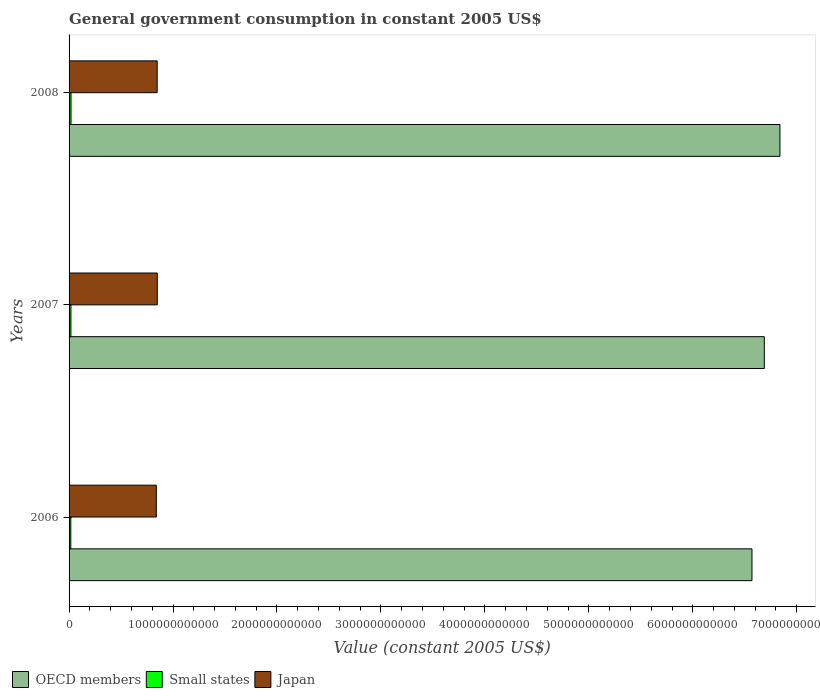How many different coloured bars are there?
Provide a short and direct response. 3. How many groups of bars are there?
Your response must be concise. 3. Are the number of bars on each tick of the Y-axis equal?
Your answer should be very brief. Yes. How many bars are there on the 1st tick from the top?
Your answer should be compact. 3. How many bars are there on the 2nd tick from the bottom?
Provide a short and direct response. 3. What is the label of the 3rd group of bars from the top?
Make the answer very short. 2006. In how many cases, is the number of bars for a given year not equal to the number of legend labels?
Ensure brevity in your answer.  0. What is the government conusmption in Small states in 2006?
Make the answer very short. 1.67e+1. Across all years, what is the maximum government conusmption in Japan?
Keep it short and to the point. 8.49e+11. Across all years, what is the minimum government conusmption in Small states?
Give a very brief answer. 1.67e+1. What is the total government conusmption in Small states in the graph?
Your answer should be compact. 5.32e+1. What is the difference between the government conusmption in Small states in 2006 and that in 2007?
Offer a very short reply. -1.14e+09. What is the difference between the government conusmption in Small states in 2006 and the government conusmption in Japan in 2008?
Make the answer very short. -8.31e+11. What is the average government conusmption in Japan per year?
Ensure brevity in your answer.  8.45e+11. In the year 2006, what is the difference between the government conusmption in Japan and government conusmption in OECD members?
Offer a terse response. -5.73e+12. In how many years, is the government conusmption in OECD members greater than 6400000000000 US$?
Offer a terse response. 3. What is the ratio of the government conusmption in OECD members in 2006 to that in 2007?
Provide a succinct answer. 0.98. Is the government conusmption in Japan in 2006 less than that in 2008?
Your answer should be compact. Yes. Is the difference between the government conusmption in Japan in 2006 and 2007 greater than the difference between the government conusmption in OECD members in 2006 and 2007?
Your answer should be compact. Yes. What is the difference between the highest and the second highest government conusmption in Small states?
Your response must be concise. 8.44e+08. What is the difference between the highest and the lowest government conusmption in Japan?
Offer a very short reply. 9.33e+09. Is the sum of the government conusmption in Japan in 2006 and 2008 greater than the maximum government conusmption in Small states across all years?
Offer a very short reply. Yes. What does the 3rd bar from the bottom in 2008 represents?
Provide a succinct answer. Japan. Is it the case that in every year, the sum of the government conusmption in OECD members and government conusmption in Japan is greater than the government conusmption in Small states?
Give a very brief answer. Yes. How many years are there in the graph?
Offer a terse response. 3. What is the difference between two consecutive major ticks on the X-axis?
Give a very brief answer. 1.00e+12. Are the values on the major ticks of X-axis written in scientific E-notation?
Give a very brief answer. No. What is the title of the graph?
Your answer should be very brief. General government consumption in constant 2005 US$. What is the label or title of the X-axis?
Your answer should be compact. Value (constant 2005 US$). What is the Value (constant 2005 US$) of OECD members in 2006?
Your answer should be very brief. 6.57e+12. What is the Value (constant 2005 US$) of Small states in 2006?
Make the answer very short. 1.67e+1. What is the Value (constant 2005 US$) in Japan in 2006?
Provide a short and direct response. 8.39e+11. What is the Value (constant 2005 US$) of OECD members in 2007?
Offer a very short reply. 6.69e+12. What is the Value (constant 2005 US$) of Small states in 2007?
Offer a terse response. 1.78e+1. What is the Value (constant 2005 US$) in Japan in 2007?
Provide a succinct answer. 8.49e+11. What is the Value (constant 2005 US$) in OECD members in 2008?
Keep it short and to the point. 6.84e+12. What is the Value (constant 2005 US$) in Small states in 2008?
Provide a short and direct response. 1.87e+1. What is the Value (constant 2005 US$) in Japan in 2008?
Make the answer very short. 8.47e+11. Across all years, what is the maximum Value (constant 2005 US$) of OECD members?
Provide a succinct answer. 6.84e+12. Across all years, what is the maximum Value (constant 2005 US$) in Small states?
Give a very brief answer. 1.87e+1. Across all years, what is the maximum Value (constant 2005 US$) in Japan?
Provide a succinct answer. 8.49e+11. Across all years, what is the minimum Value (constant 2005 US$) in OECD members?
Your answer should be very brief. 6.57e+12. Across all years, what is the minimum Value (constant 2005 US$) in Small states?
Provide a short and direct response. 1.67e+1. Across all years, what is the minimum Value (constant 2005 US$) of Japan?
Your response must be concise. 8.39e+11. What is the total Value (constant 2005 US$) of OECD members in the graph?
Keep it short and to the point. 2.01e+13. What is the total Value (constant 2005 US$) of Small states in the graph?
Your answer should be very brief. 5.32e+1. What is the total Value (constant 2005 US$) of Japan in the graph?
Provide a short and direct response. 2.54e+12. What is the difference between the Value (constant 2005 US$) of OECD members in 2006 and that in 2007?
Your answer should be very brief. -1.19e+11. What is the difference between the Value (constant 2005 US$) of Small states in 2006 and that in 2007?
Your answer should be very brief. -1.14e+09. What is the difference between the Value (constant 2005 US$) of Japan in 2006 and that in 2007?
Make the answer very short. -9.33e+09. What is the difference between the Value (constant 2005 US$) in OECD members in 2006 and that in 2008?
Give a very brief answer. -2.69e+11. What is the difference between the Value (constant 2005 US$) of Small states in 2006 and that in 2008?
Your answer should be very brief. -1.98e+09. What is the difference between the Value (constant 2005 US$) in Japan in 2006 and that in 2008?
Your answer should be compact. -8.26e+09. What is the difference between the Value (constant 2005 US$) in OECD members in 2007 and that in 2008?
Your response must be concise. -1.50e+11. What is the difference between the Value (constant 2005 US$) in Small states in 2007 and that in 2008?
Provide a succinct answer. -8.44e+08. What is the difference between the Value (constant 2005 US$) in Japan in 2007 and that in 2008?
Keep it short and to the point. 1.07e+09. What is the difference between the Value (constant 2005 US$) of OECD members in 2006 and the Value (constant 2005 US$) of Small states in 2007?
Your response must be concise. 6.55e+12. What is the difference between the Value (constant 2005 US$) of OECD members in 2006 and the Value (constant 2005 US$) of Japan in 2007?
Your response must be concise. 5.72e+12. What is the difference between the Value (constant 2005 US$) in Small states in 2006 and the Value (constant 2005 US$) in Japan in 2007?
Ensure brevity in your answer.  -8.32e+11. What is the difference between the Value (constant 2005 US$) in OECD members in 2006 and the Value (constant 2005 US$) in Small states in 2008?
Keep it short and to the point. 6.55e+12. What is the difference between the Value (constant 2005 US$) in OECD members in 2006 and the Value (constant 2005 US$) in Japan in 2008?
Provide a short and direct response. 5.72e+12. What is the difference between the Value (constant 2005 US$) in Small states in 2006 and the Value (constant 2005 US$) in Japan in 2008?
Offer a very short reply. -8.31e+11. What is the difference between the Value (constant 2005 US$) of OECD members in 2007 and the Value (constant 2005 US$) of Small states in 2008?
Your answer should be very brief. 6.67e+12. What is the difference between the Value (constant 2005 US$) of OECD members in 2007 and the Value (constant 2005 US$) of Japan in 2008?
Make the answer very short. 5.84e+12. What is the difference between the Value (constant 2005 US$) in Small states in 2007 and the Value (constant 2005 US$) in Japan in 2008?
Offer a terse response. -8.30e+11. What is the average Value (constant 2005 US$) in OECD members per year?
Offer a very short reply. 6.70e+12. What is the average Value (constant 2005 US$) of Small states per year?
Offer a terse response. 1.77e+1. What is the average Value (constant 2005 US$) of Japan per year?
Provide a succinct answer. 8.45e+11. In the year 2006, what is the difference between the Value (constant 2005 US$) in OECD members and Value (constant 2005 US$) in Small states?
Ensure brevity in your answer.  6.55e+12. In the year 2006, what is the difference between the Value (constant 2005 US$) of OECD members and Value (constant 2005 US$) of Japan?
Ensure brevity in your answer.  5.73e+12. In the year 2006, what is the difference between the Value (constant 2005 US$) of Small states and Value (constant 2005 US$) of Japan?
Ensure brevity in your answer.  -8.22e+11. In the year 2007, what is the difference between the Value (constant 2005 US$) of OECD members and Value (constant 2005 US$) of Small states?
Keep it short and to the point. 6.67e+12. In the year 2007, what is the difference between the Value (constant 2005 US$) of OECD members and Value (constant 2005 US$) of Japan?
Provide a succinct answer. 5.84e+12. In the year 2007, what is the difference between the Value (constant 2005 US$) in Small states and Value (constant 2005 US$) in Japan?
Your answer should be compact. -8.31e+11. In the year 2008, what is the difference between the Value (constant 2005 US$) of OECD members and Value (constant 2005 US$) of Small states?
Your answer should be compact. 6.82e+12. In the year 2008, what is the difference between the Value (constant 2005 US$) in OECD members and Value (constant 2005 US$) in Japan?
Offer a very short reply. 5.99e+12. In the year 2008, what is the difference between the Value (constant 2005 US$) of Small states and Value (constant 2005 US$) of Japan?
Offer a terse response. -8.29e+11. What is the ratio of the Value (constant 2005 US$) in OECD members in 2006 to that in 2007?
Your answer should be compact. 0.98. What is the ratio of the Value (constant 2005 US$) of Small states in 2006 to that in 2007?
Your answer should be compact. 0.94. What is the ratio of the Value (constant 2005 US$) of OECD members in 2006 to that in 2008?
Give a very brief answer. 0.96. What is the ratio of the Value (constant 2005 US$) of Small states in 2006 to that in 2008?
Your answer should be very brief. 0.89. What is the ratio of the Value (constant 2005 US$) of Japan in 2006 to that in 2008?
Keep it short and to the point. 0.99. What is the ratio of the Value (constant 2005 US$) of OECD members in 2007 to that in 2008?
Offer a very short reply. 0.98. What is the ratio of the Value (constant 2005 US$) in Small states in 2007 to that in 2008?
Your response must be concise. 0.95. What is the difference between the highest and the second highest Value (constant 2005 US$) of OECD members?
Offer a very short reply. 1.50e+11. What is the difference between the highest and the second highest Value (constant 2005 US$) in Small states?
Keep it short and to the point. 8.44e+08. What is the difference between the highest and the second highest Value (constant 2005 US$) in Japan?
Provide a succinct answer. 1.07e+09. What is the difference between the highest and the lowest Value (constant 2005 US$) of OECD members?
Provide a short and direct response. 2.69e+11. What is the difference between the highest and the lowest Value (constant 2005 US$) in Small states?
Ensure brevity in your answer.  1.98e+09. What is the difference between the highest and the lowest Value (constant 2005 US$) of Japan?
Offer a terse response. 9.33e+09. 